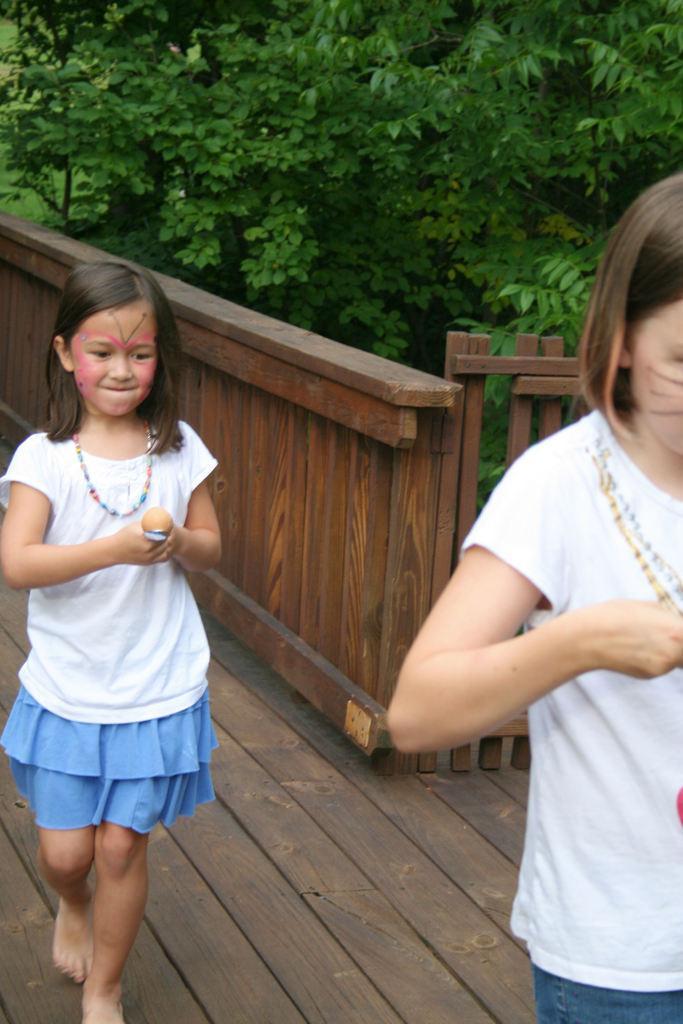In one or two sentences, can you explain what this image depicts? In the center of the image there are two girls walking and holding spoons. In the background there is a fence and we can see trees. 